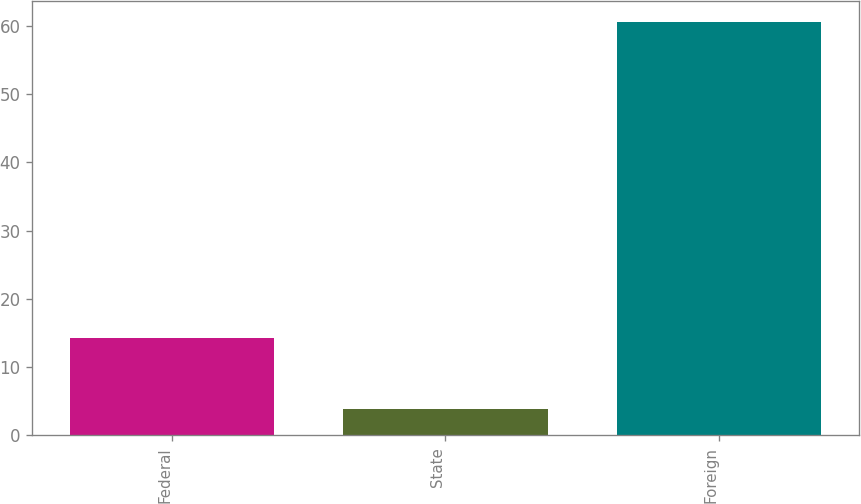<chart> <loc_0><loc_0><loc_500><loc_500><bar_chart><fcel>Federal<fcel>State<fcel>Foreign<nl><fcel>14.3<fcel>3.8<fcel>60.6<nl></chart> 